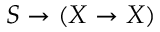<formula> <loc_0><loc_0><loc_500><loc_500>S \to ( X \to X )</formula> 